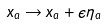<formula> <loc_0><loc_0><loc_500><loc_500>x _ { a } \rightarrow x _ { a } + \epsilon \eta _ { a }</formula> 